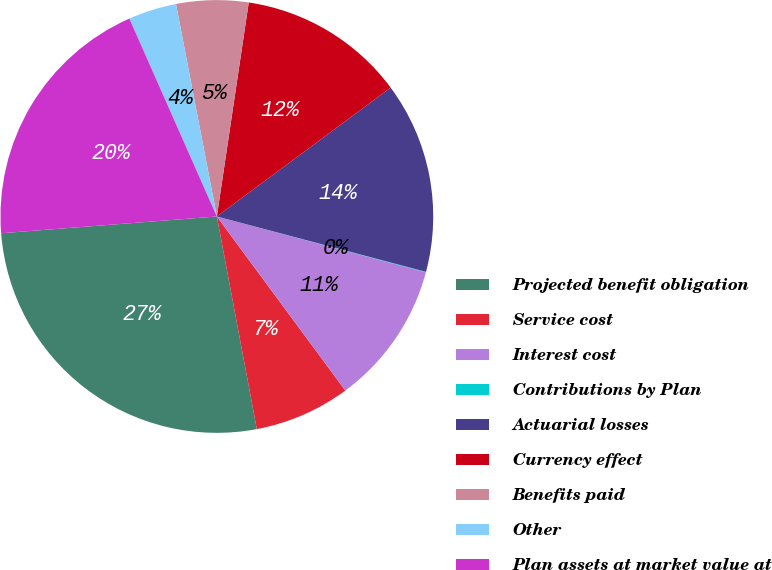Convert chart to OTSL. <chart><loc_0><loc_0><loc_500><loc_500><pie_chart><fcel>Projected benefit obligation<fcel>Service cost<fcel>Interest cost<fcel>Contributions by Plan<fcel>Actuarial losses<fcel>Currency effect<fcel>Benefits paid<fcel>Other<fcel>Plan assets at market value at<nl><fcel>26.72%<fcel>7.16%<fcel>10.72%<fcel>0.04%<fcel>14.27%<fcel>12.49%<fcel>5.38%<fcel>3.6%<fcel>19.61%<nl></chart> 